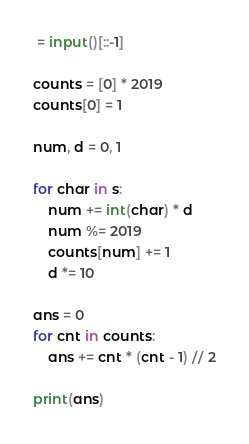Convert code to text. <code><loc_0><loc_0><loc_500><loc_500><_Python_> = input()[::-1]

counts = [0] * 2019
counts[0] = 1

num, d = 0, 1

for char in s:
    num += int(char) * d
    num %= 2019
    counts[num] += 1
    d *= 10

ans = 0
for cnt in counts:
    ans += cnt * (cnt - 1) // 2
    
print(ans)</code> 